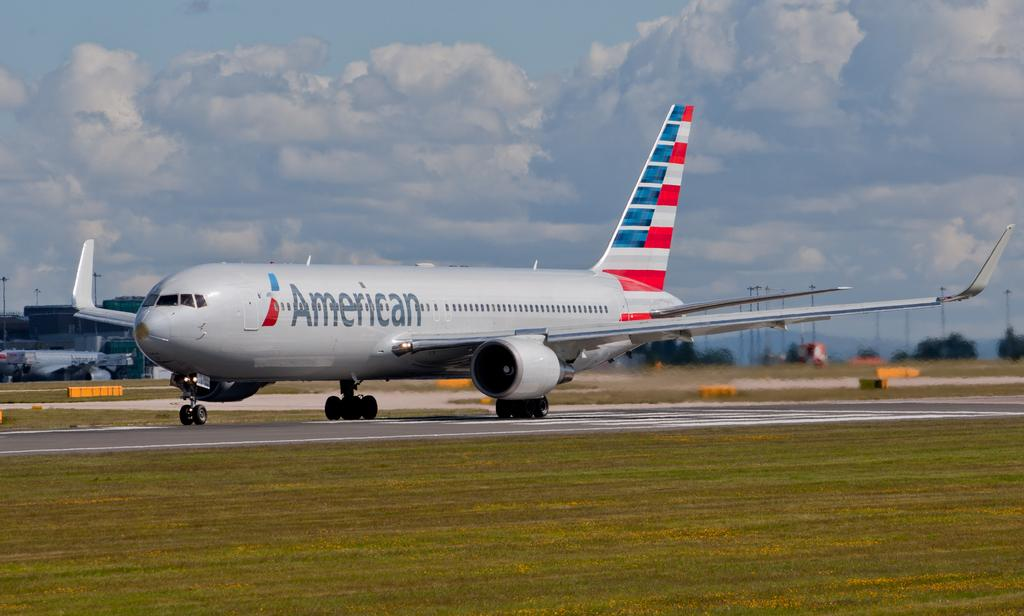<image>
Render a clear and concise summary of the photo. An airplane with the word American written on the side 